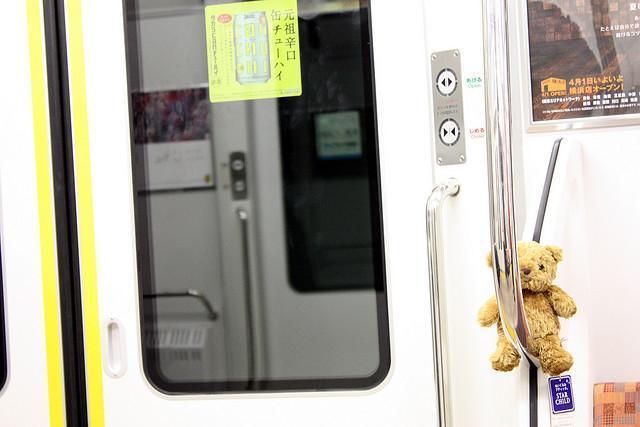How many chairs or sofas have a red pillow?
Give a very brief answer. 0. 